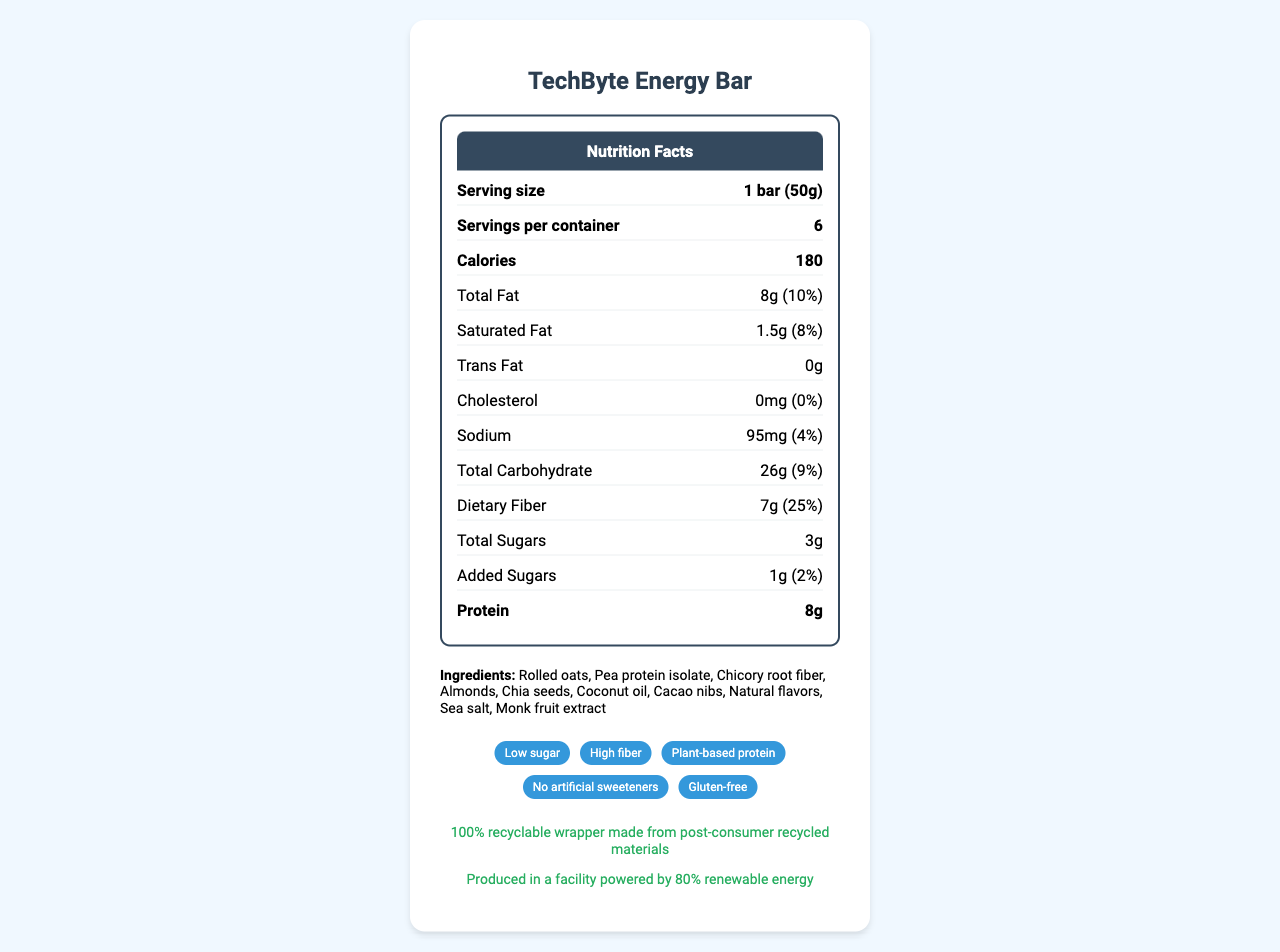what is the serving size for TechByte Energy Bar? The serving size is clearly listed as "1 bar (50g)" in the nutrition facts label.
Answer: 1 bar (50g) how many calories are in one serving of TechByte Energy Bar? The calories count per serving is listed as 180.
Answer: 180 how much dietary fiber does one TechByte Energy Bar contain? The document states that the dietary fiber content is 7g.
Answer: 7g what percentage of the daily value of total fat does one TechByte Energy Bar provide? This is stated as "Total Fat: 8g (10%)" in the nutrition facts.
Answer: 10% list some of the ingredients in the TechByte Energy Bar. These are some of the ingredients listed in the document.
Answer: Rolled oats, Pea protein isolate, Chicory root fiber, Almonds how many servings are there per container? A. 4 B. 6 C. 8 The document specifies "servings per container: 6."
Answer: B which nutrient has the highest daily value percentage in one serving? A. Saturated Fat B. Dietary Fiber C. Sodium D. Protein Dietary Fiber has the highest daily value percentage at 25%.
Answer: B is the TechByte Energy Bar gluten-free? One of the marketing claims on the document lists "Gluten-free."
Answer: Yes does the TechByte Energy Bar contain added sugars? The document states there are "Added Sugars: 1g (2%)."
Answer: Yes summarize the key features of the TechByte Energy Bar. The document provides detailed information on the nutrition facts, ingredients, marketing claims, and sustainability efforts of the TechByte Energy Bar, highlighting its low sugar content, high fiber, plant-based protein, and environmentally friendly production.
Answer: The TechByte Energy Bar is a low-sugar, high-fiber snack bar designed for IT professionals and tech enthusiasts. Each 50g bar has 180 calories, contains 8g of protein, and provides 25% of the daily value for dietary fiber. It is gluten-free, contains plant-based protein, and is manufactured using sustainable practices. Ingredients include rolled oats, pea protein isolate, and almonds. what is the daily value percentage of calcium in one serving? The document states that the daily value percentage for calcium is 4%.
Answer: 4% how much sodium does one TechByte Energy Bar contain? The sodium content is listed as 95mg (4% daily value).
Answer: 95mg are there any trans fats in the TechByte Energy Bar? The document states "Trans Fat: 0g."
Answer: No can you determine how much vitamin C is in the TechByte Energy Bar? The document does not provide any information on the vitamin C content.
Answer: Not enough information 